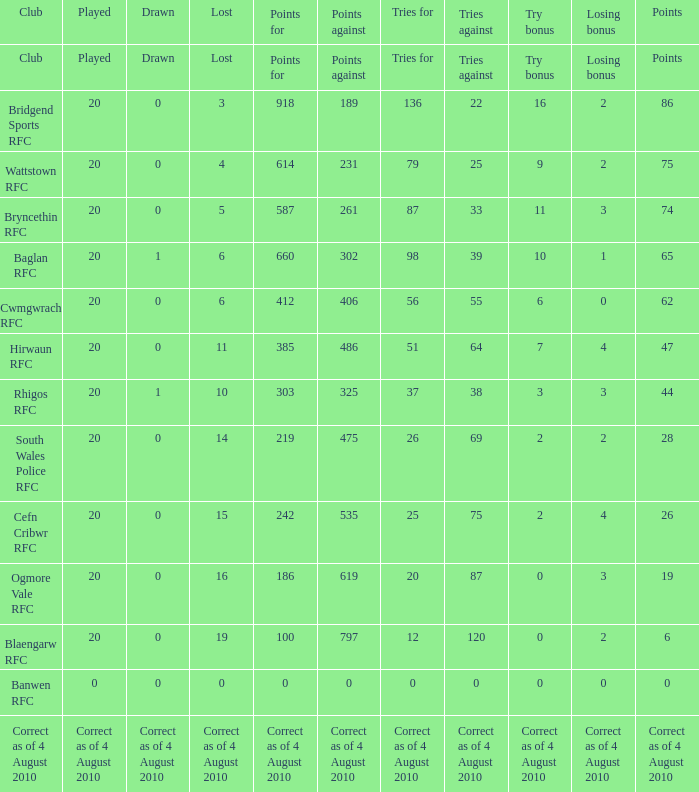What is the efforts for when losing bonus is giving up bonus? Tries for. 